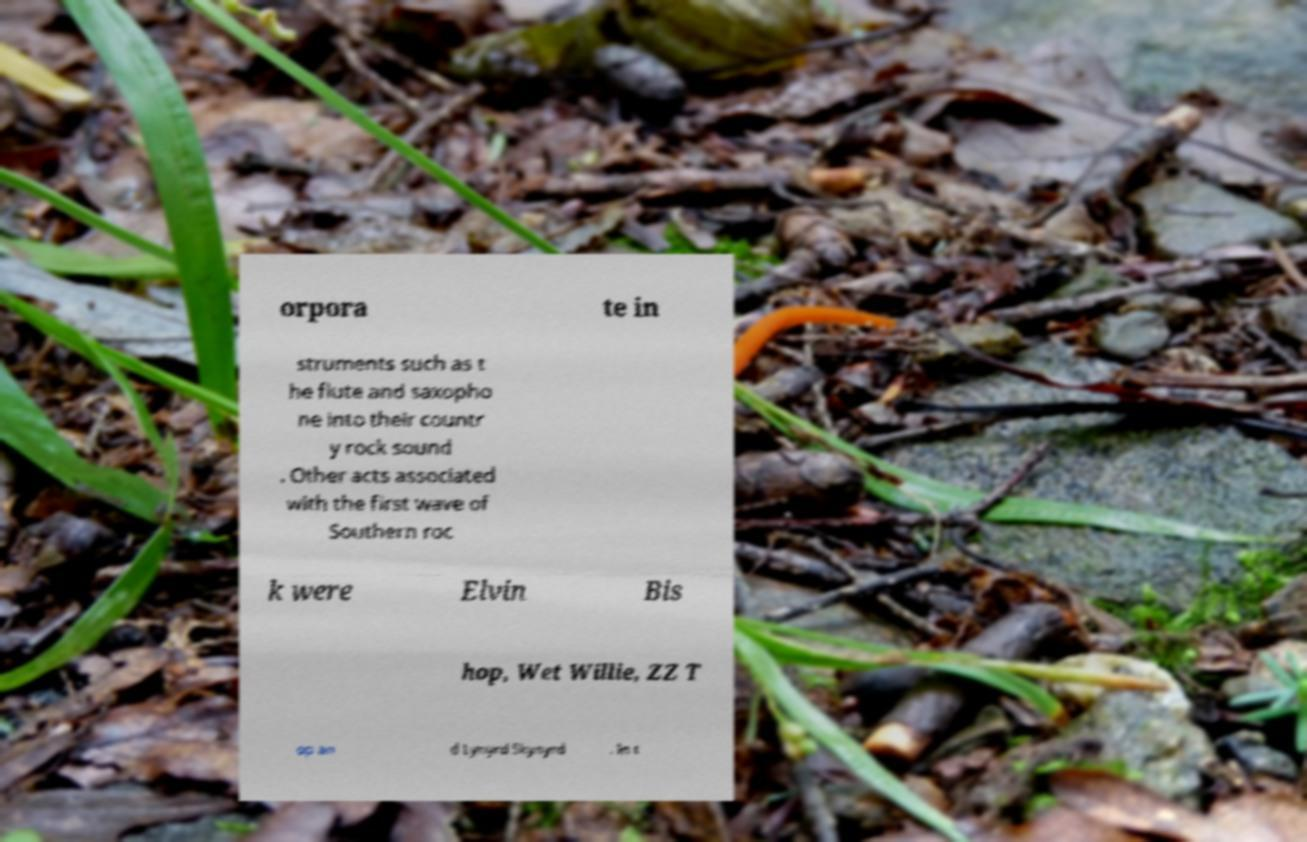Could you extract and type out the text from this image? orpora te in struments such as t he flute and saxopho ne into their countr y rock sound . Other acts associated with the first wave of Southern roc k were Elvin Bis hop, Wet Willie, ZZ T op an d Lynyrd Skynyrd . In t 